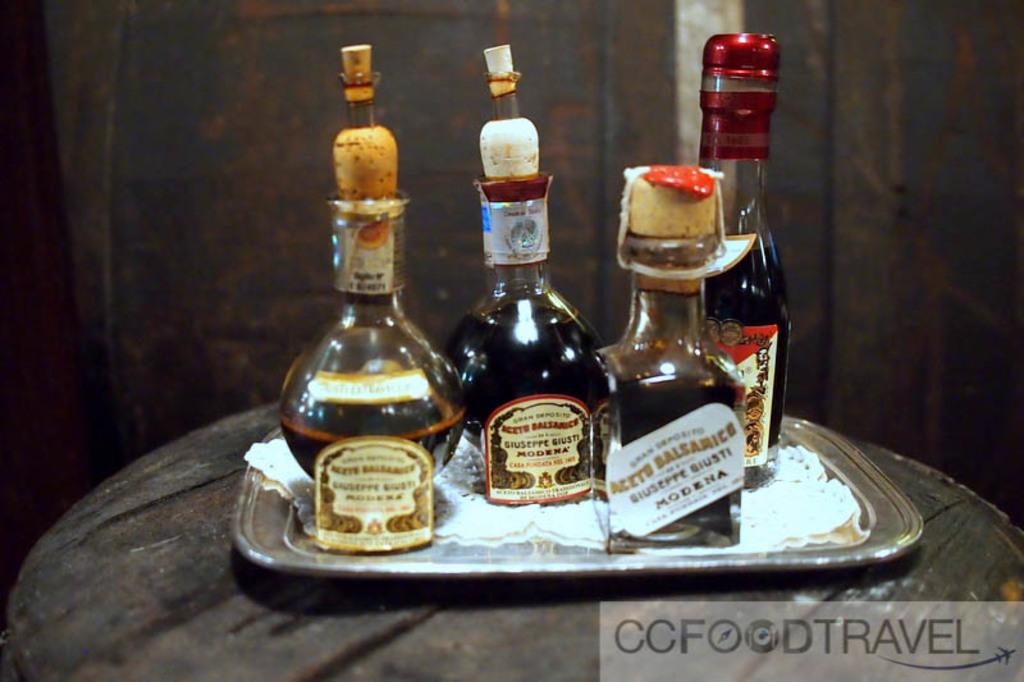What type of travel?
Offer a very short reply. Ccfood. 